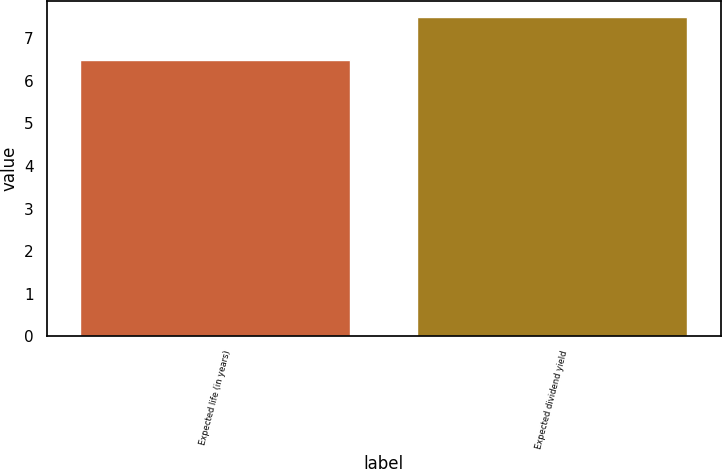Convert chart. <chart><loc_0><loc_0><loc_500><loc_500><bar_chart><fcel>Expected life (in years)<fcel>Expected dividend yield<nl><fcel>6.5<fcel>7.5<nl></chart> 